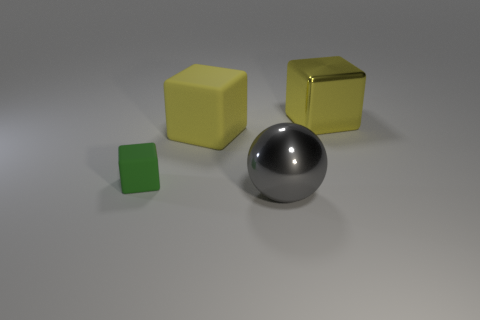What could the significance of the color variation among the cubes be? The variation in color among the cubes could be a way to distinguish them from each other, perhaps indicating different categories or purposes if this were part of a color-coded system. What could those categories or purposes be? Possibly, in an educational context, the yellow cubes might represent one concept, while the green cube represents another. It's also plausible that, in a gaming environment, the colors indicate different levels of power or resources. 